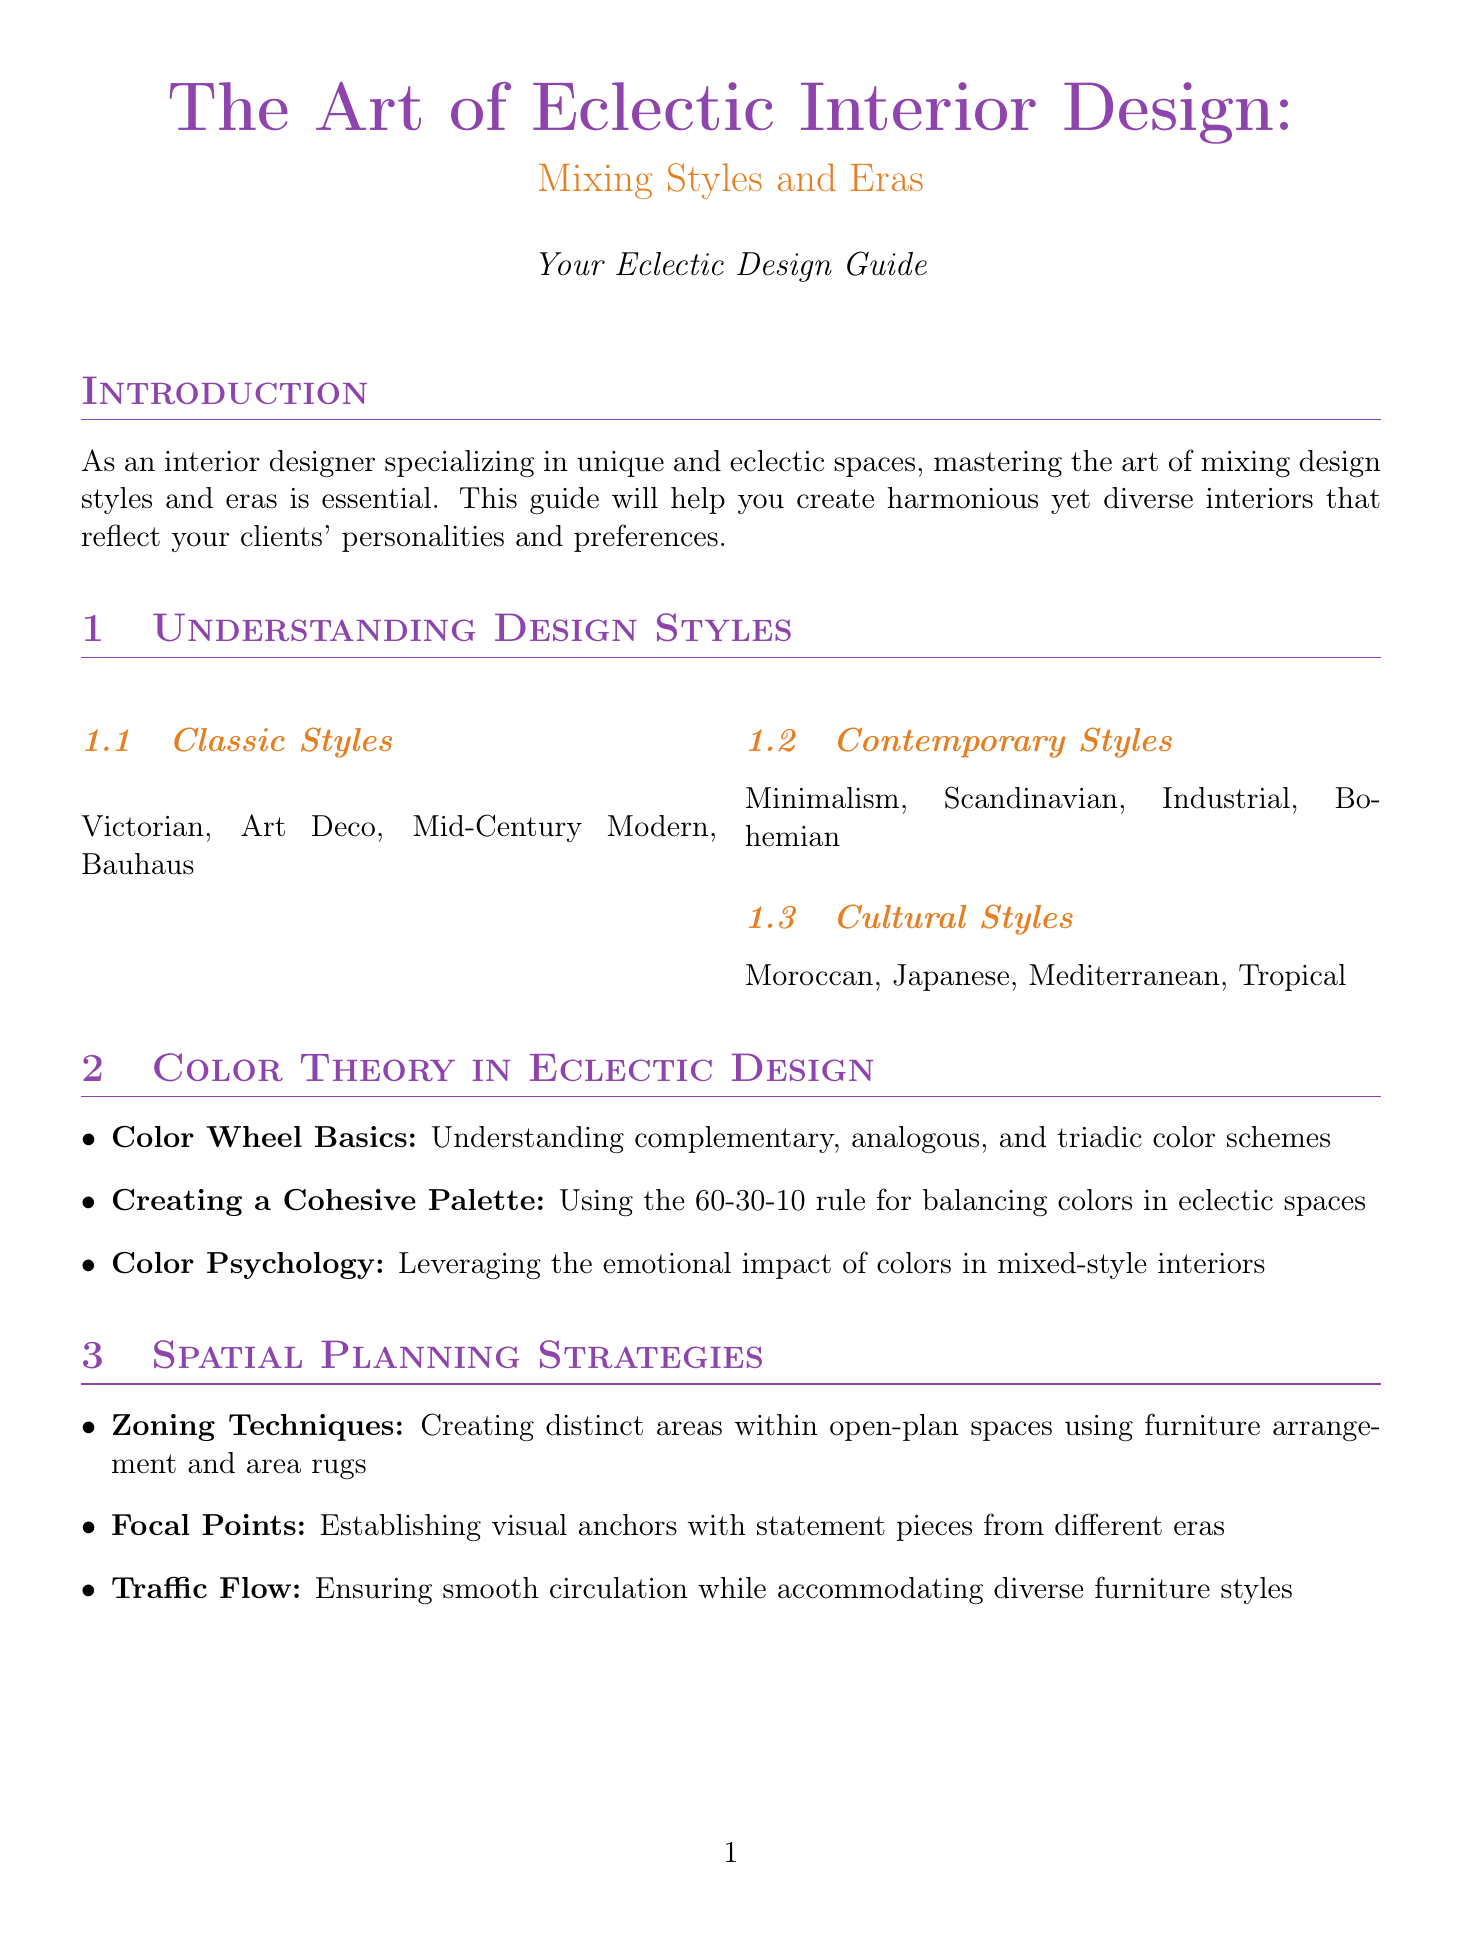What is the title of the document? The title is presented at the beginning and reflects the main subject matter of the document.
Answer: The Art of Eclectic Interior Design: Mixing Styles and Eras How many design styles are mentioned in the Understanding Design Styles section? The section lists three main categories of design styles, and each category includes multiple styles.
Answer: 3 What rule is mentioned for creating a cohesive color palette? The document outlines a specific rule that helps maintain color balance in eclectic designs.
Answer: 60-30-10 rule What is a recommended technique for zoning in open-plan spaces? The document provides strategies for spatial planning, particularly in open areas, with specific furniture arrangements.
Answer: Furniture arrangement Which case study features a blend of Victorian and Industrial styles? The document includes specific examples of interiors that mix various styles, indicating one specific case study title.
Answer: Victorian Meets Industrial Name one online platform suggested for sourcing unique pieces. The document lists various platforms for finding one-of-a-kind items, focusing on popular online options.
Answer: 1stDibs What is suggested for helping clients understand design choices? This information is located in the Client Communication section and provides a tool to facilitate client understanding.
Answer: Education and Guidance How many case studies are included in the document? The document enumerates specific case studies, which allows us to determine the total count presented.
Answer: 3 